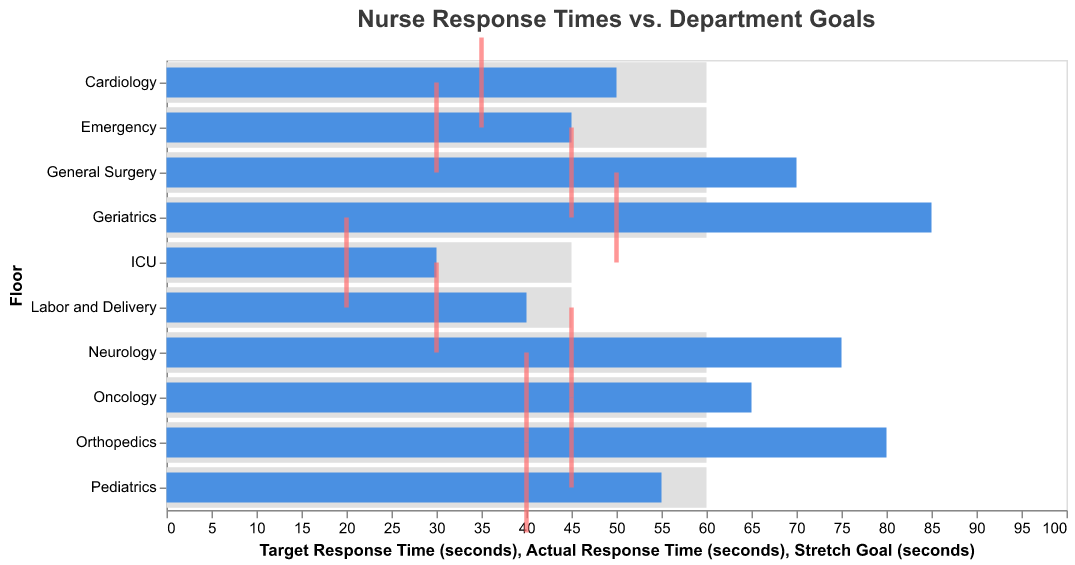What is the title of the bullet chart? The title is displayed at the top of the chart, summarizing the data presented.
Answer: Nurse Response Times vs. Department Goals Which floor has the fastest actual response time? By examining the blue bars representing actual response times, the shortest bar indicates the fastest response time.
Answer: ICU Is there any floor where the actual response time met or was below the target response time? Compare the length of the blue bars with the grey bars for each floor.
Answer: ICU, Emergency, Labor and Delivery, Pediatrics, Cardiology How does the Emergency floor compare to its target and stretch goals? Observe the lengths of the blue bar, grey bar, and red tick for the Emergency floor. The blue bar for actual response time is shorter than the grey bar for the target but longer than the red tick for the stretch goal.
Answer: Above stretch goal, below target goal What is the difference between the actual response time and the stretch goal for General Surgery? Find the actual response time (blue bar) and the stretch goal (red tick) for General Surgery, and subtract the stretch goal from the actual response time.
Answer: 70 - 45 = 25 seconds Which floor has the largest gap between the actual and target response time? Compare the differences between the lengths of the blue bars and the grey bars for all floors.
Answer: Geriatrics Are there any floors where the actual response time exceeds the target response time by more than 15 seconds? For each floor, subtract the target response time from the actual response time and identify any floor where this difference is greater than 15 seconds.
Answer: Geriatrics, Orthopedics, Neurology What is the average stretch goal time across all floors? Add all the stretch goal times (red ticks), then divide by the number of floors to find the average.
Answer: (30 + 20 + 40 + 45 + 40 + 45 + 35 + 30 + 45 + 50) / 10 = 38 seconds Which floor has the closest actual response time to its stretch goal? Compare the actual response time (blue bars) to the stretch goal (red ticks) for each floor and find the smallest difference.
Answer: ICU How do response times in the Pediatrics department compare to the Oncology department? Compare the actual (blue bars), target (grey bars), and stretch goals (red ticks) between Pediatrics and Oncology. Pediatrics has a shorter actual response time than Oncology but both have the same target response time.
Answer: Pediatrics is faster 